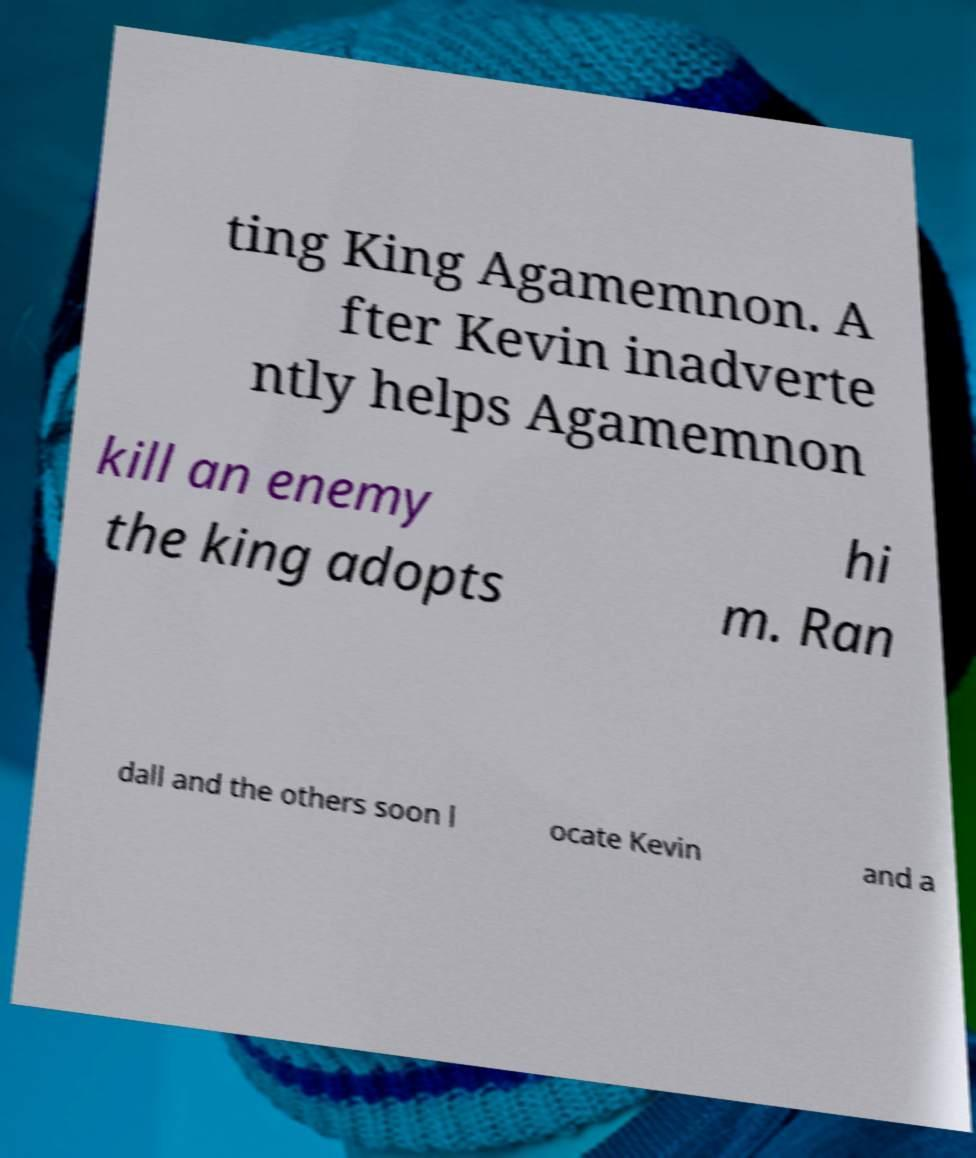There's text embedded in this image that I need extracted. Can you transcribe it verbatim? ting King Agamemnon. A fter Kevin inadverte ntly helps Agamemnon kill an enemy the king adopts hi m. Ran dall and the others soon l ocate Kevin and a 